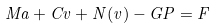<formula> <loc_0><loc_0><loc_500><loc_500>M a + C v + N ( v ) - G P = F</formula> 